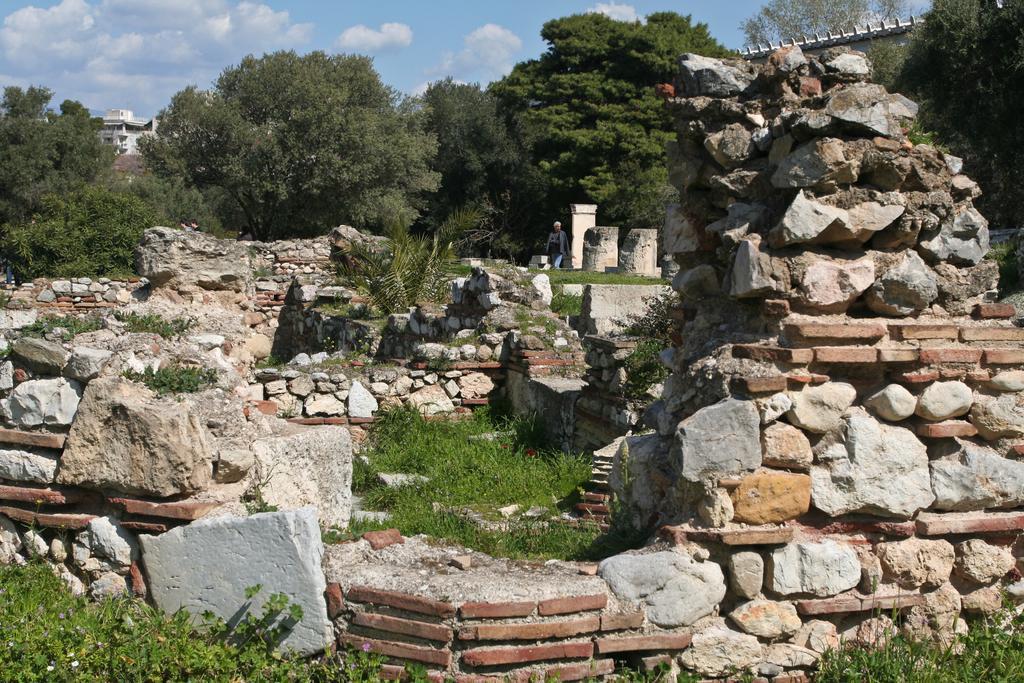In one or two sentences, can you explain what this image depicts? In the image we can see stones and bricks. We can see grass, trees, buildings and the cloudy pale blue sky. We can even see a person walking and wearing clothes. 